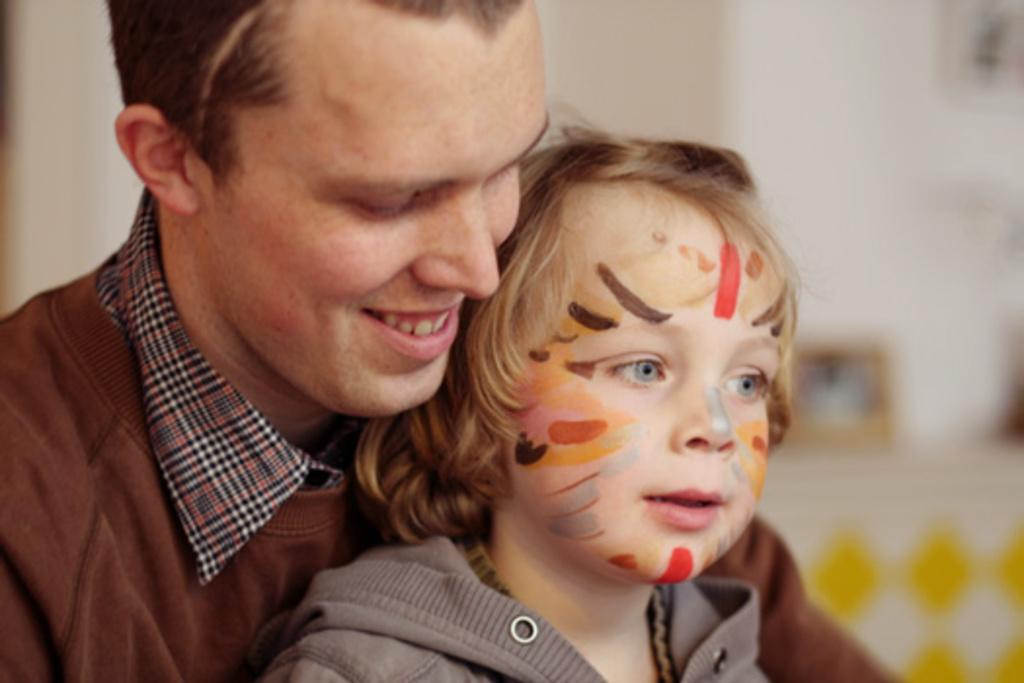Who is present in the image? There is a man and a child in the image. What can be seen in the background of the image? There are objects on a table and a wall visible in the background of the image. What type of store can be seen in the background of the image? There is no store visible in the background of the image. 